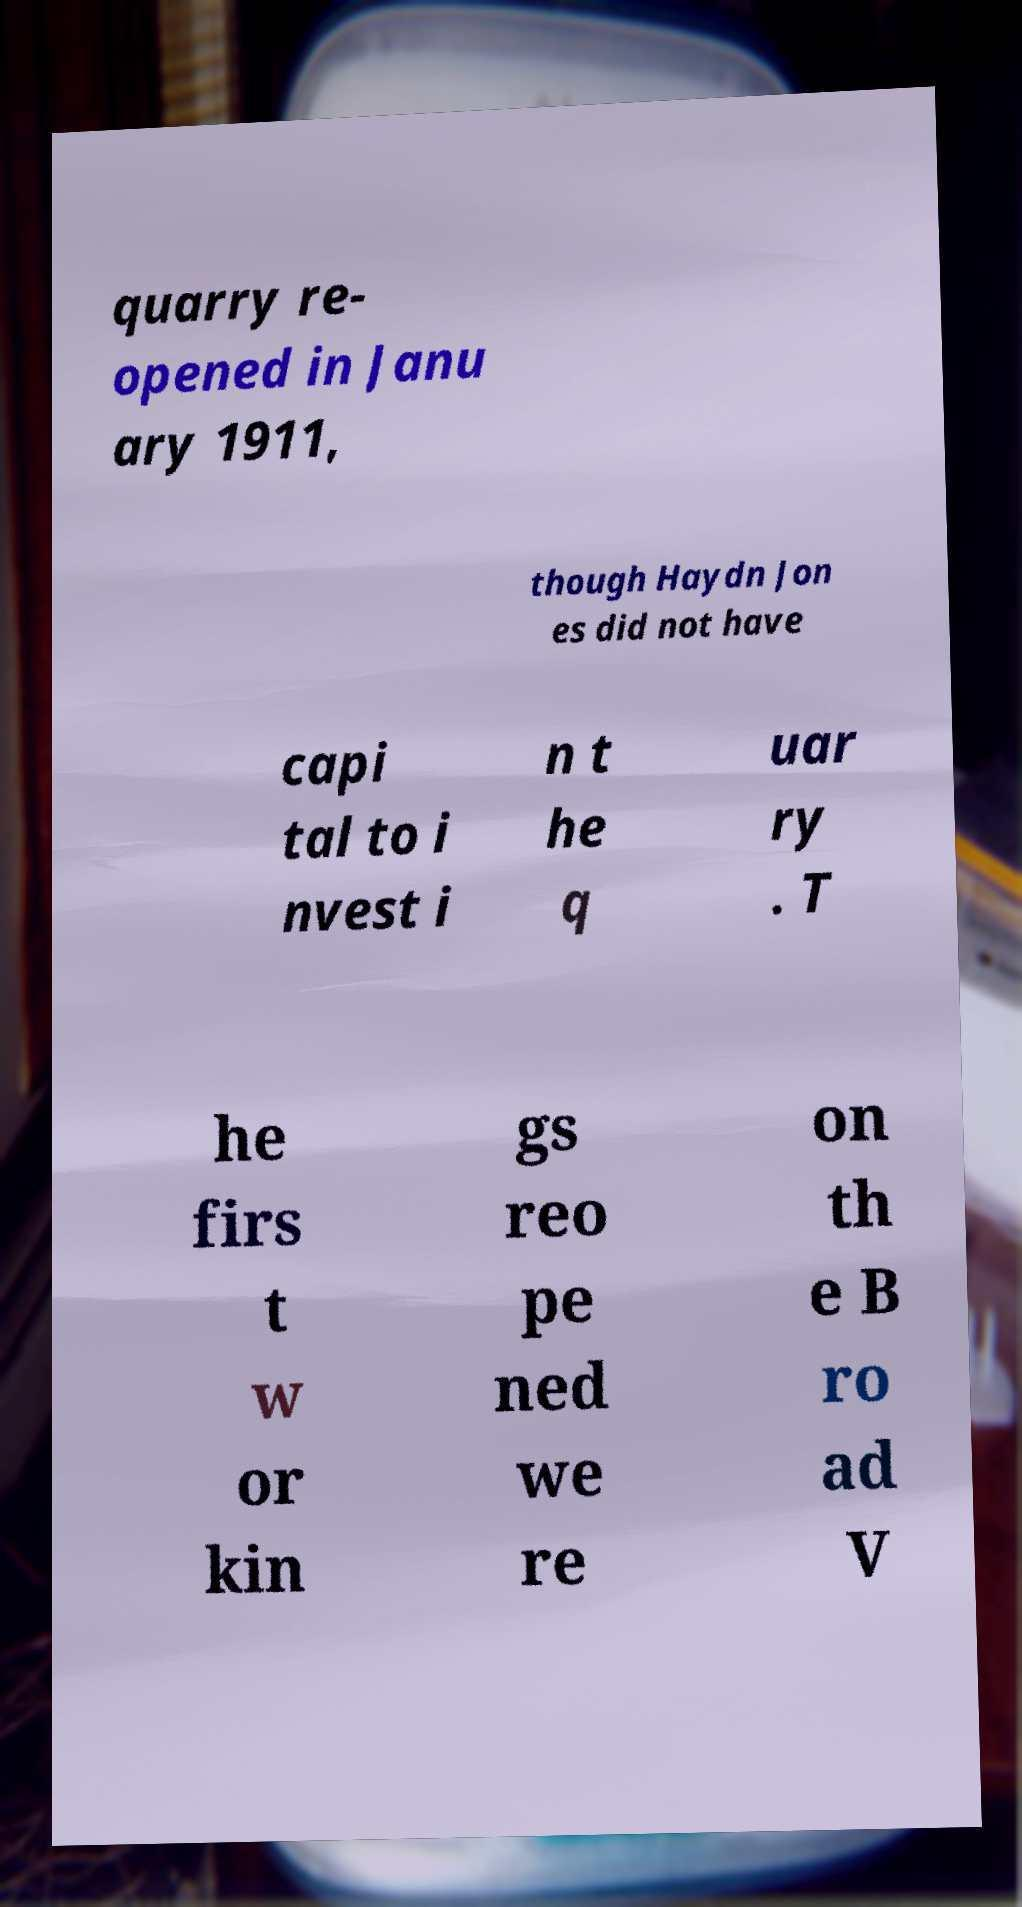Please read and relay the text visible in this image. What does it say? quarry re- opened in Janu ary 1911, though Haydn Jon es did not have capi tal to i nvest i n t he q uar ry . T he firs t w or kin gs reo pe ned we re on th e B ro ad V 